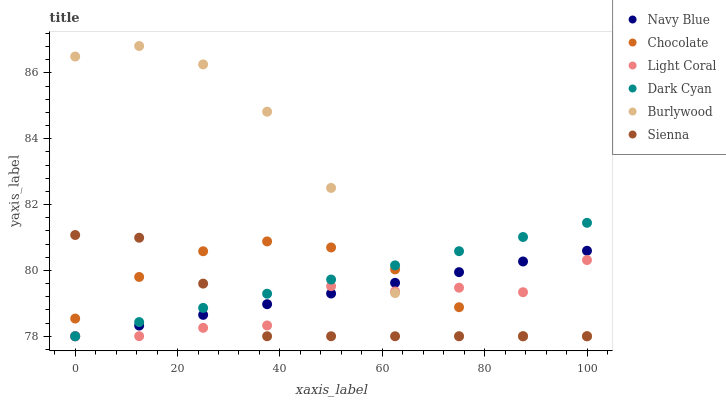Does Sienna have the minimum area under the curve?
Answer yes or no. Yes. Does Burlywood have the maximum area under the curve?
Answer yes or no. Yes. Does Navy Blue have the minimum area under the curve?
Answer yes or no. No. Does Navy Blue have the maximum area under the curve?
Answer yes or no. No. Is Dark Cyan the smoothest?
Answer yes or no. Yes. Is Burlywood the roughest?
Answer yes or no. Yes. Is Navy Blue the smoothest?
Answer yes or no. No. Is Navy Blue the roughest?
Answer yes or no. No. Does Sienna have the lowest value?
Answer yes or no. Yes. Does Burlywood have the highest value?
Answer yes or no. Yes. Does Navy Blue have the highest value?
Answer yes or no. No. Does Chocolate intersect Navy Blue?
Answer yes or no. Yes. Is Chocolate less than Navy Blue?
Answer yes or no. No. Is Chocolate greater than Navy Blue?
Answer yes or no. No. 